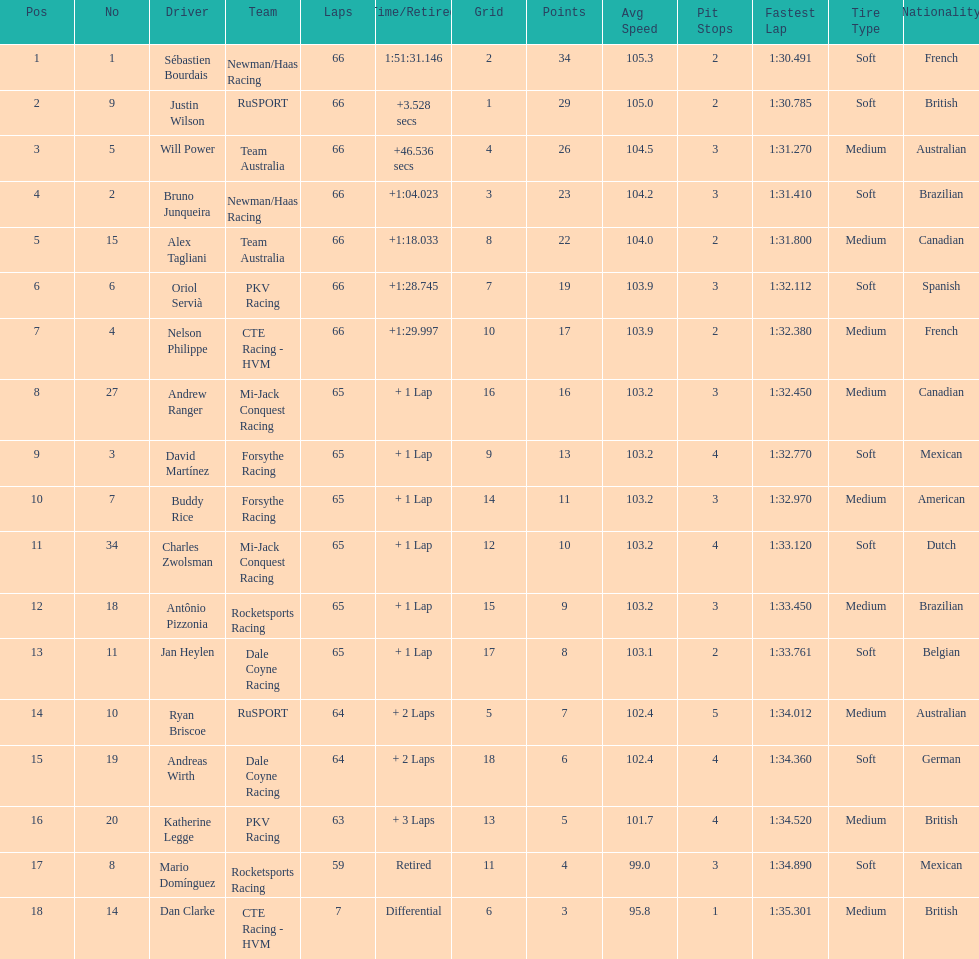Who finished directly after the driver who finished in 1:28.745? Nelson Philippe. 